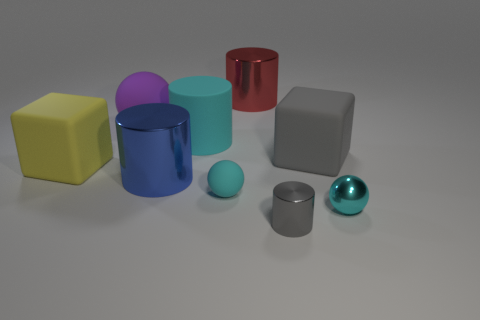What number of objects are cylinders behind the small cylinder or cyan objects that are right of the big cyan rubber cylinder?
Make the answer very short. 5. What color is the tiny shiny object that is the same shape as the large red thing?
Make the answer very short. Gray. What number of tiny rubber spheres have the same color as the large matte cylinder?
Offer a terse response. 1. Is the color of the tiny cylinder the same as the small metal ball?
Provide a short and direct response. No. How many objects are metallic cylinders in front of the gray matte object or large purple matte objects?
Offer a terse response. 3. The big metallic cylinder that is behind the gray thing that is behind the large metal cylinder in front of the large gray object is what color?
Provide a succinct answer. Red. There is a sphere that is the same material as the large blue thing; what is its color?
Provide a succinct answer. Cyan. How many other small cylinders are made of the same material as the tiny cylinder?
Offer a terse response. 0. Do the gray thing in front of the gray cube and the cyan cylinder have the same size?
Give a very brief answer. No. The rubber sphere that is the same size as the metallic sphere is what color?
Your answer should be very brief. Cyan. 